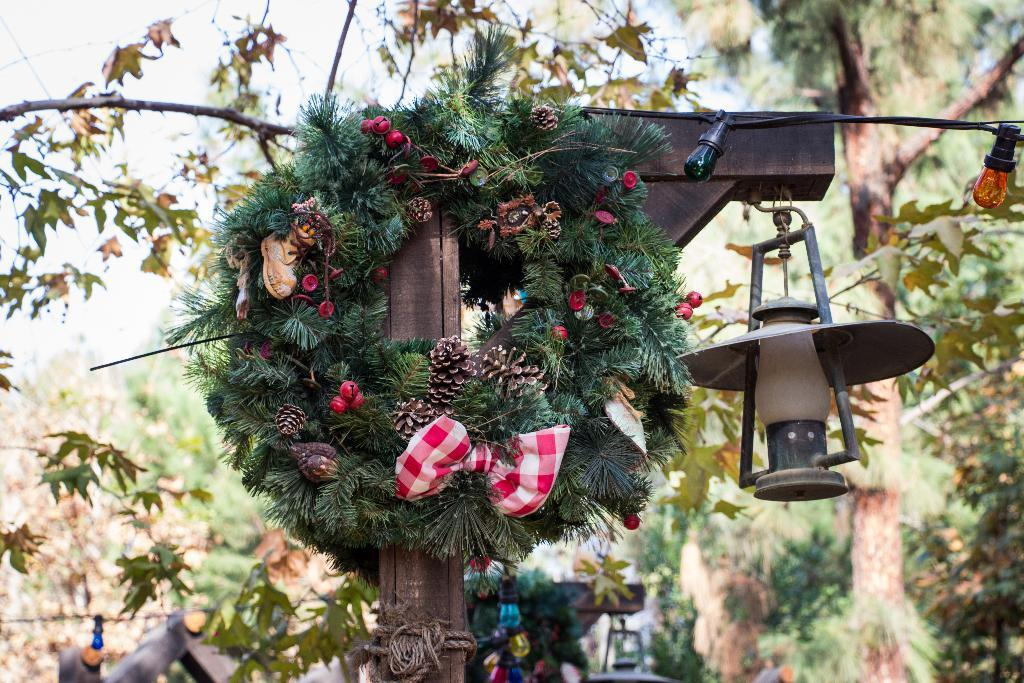What type of decorative items can be seen in the image? There are fancy garlands in the image. What animal is present in the image? There is a lamb in the image. What material is used to create the object in the image? There is a wooden object in the image. What can be seen in the distance in the image? Trees are visible in the background of the image. How many shoes are on the lamb's feet in the image? There are no shoes present on the lamb's feet in the image. What type of horse can be seen in the image? There is no horse present in the image; it features a lamb instead. 